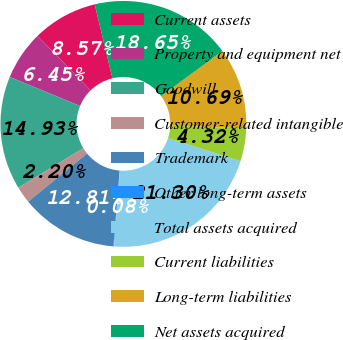Convert chart to OTSL. <chart><loc_0><loc_0><loc_500><loc_500><pie_chart><fcel>Current assets<fcel>Property and equipment net<fcel>Goodwill<fcel>Customer-related intangible<fcel>Trademark<fcel>Other long-term assets<fcel>Total assets acquired<fcel>Current liabilities<fcel>Long-term liabilities<fcel>Net assets acquired<nl><fcel>8.57%<fcel>6.45%<fcel>14.93%<fcel>2.2%<fcel>12.81%<fcel>0.08%<fcel>21.3%<fcel>4.32%<fcel>10.69%<fcel>18.65%<nl></chart> 